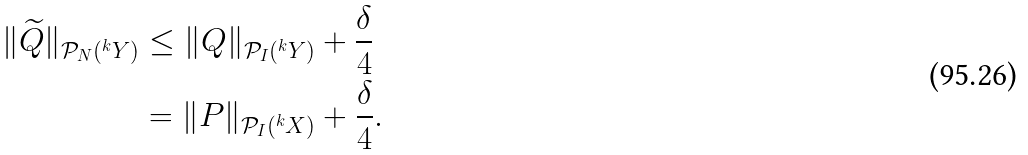Convert formula to latex. <formula><loc_0><loc_0><loc_500><loc_500>\| \widetilde { Q } \| _ { \mathcal { P } _ { N } ( ^ { k } Y ) } & \leq \| Q \| _ { \mathcal { P } _ { I } ( ^ { k } Y ) } + \frac { \delta } { 4 } \\ & = \| P \| _ { \mathcal { P } _ { I } ( ^ { k } X ) } + \frac { \delta } { 4 } .</formula> 